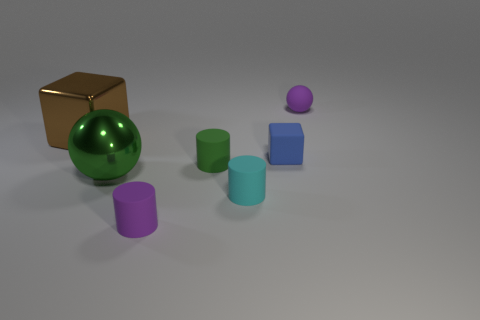Add 2 big metal objects. How many objects exist? 9 Subtract 2 cylinders. How many cylinders are left? 1 Subtract all tiny green matte cylinders. How many cylinders are left? 2 Subtract all blocks. How many objects are left? 5 Subtract all brown spheres. Subtract all cyan cubes. How many spheres are left? 2 Subtract all gray spheres. How many gray blocks are left? 0 Subtract all tiny rubber cylinders. Subtract all large objects. How many objects are left? 2 Add 1 small green things. How many small green things are left? 2 Add 2 tiny red things. How many tiny red things exist? 2 Subtract all blue blocks. How many blocks are left? 1 